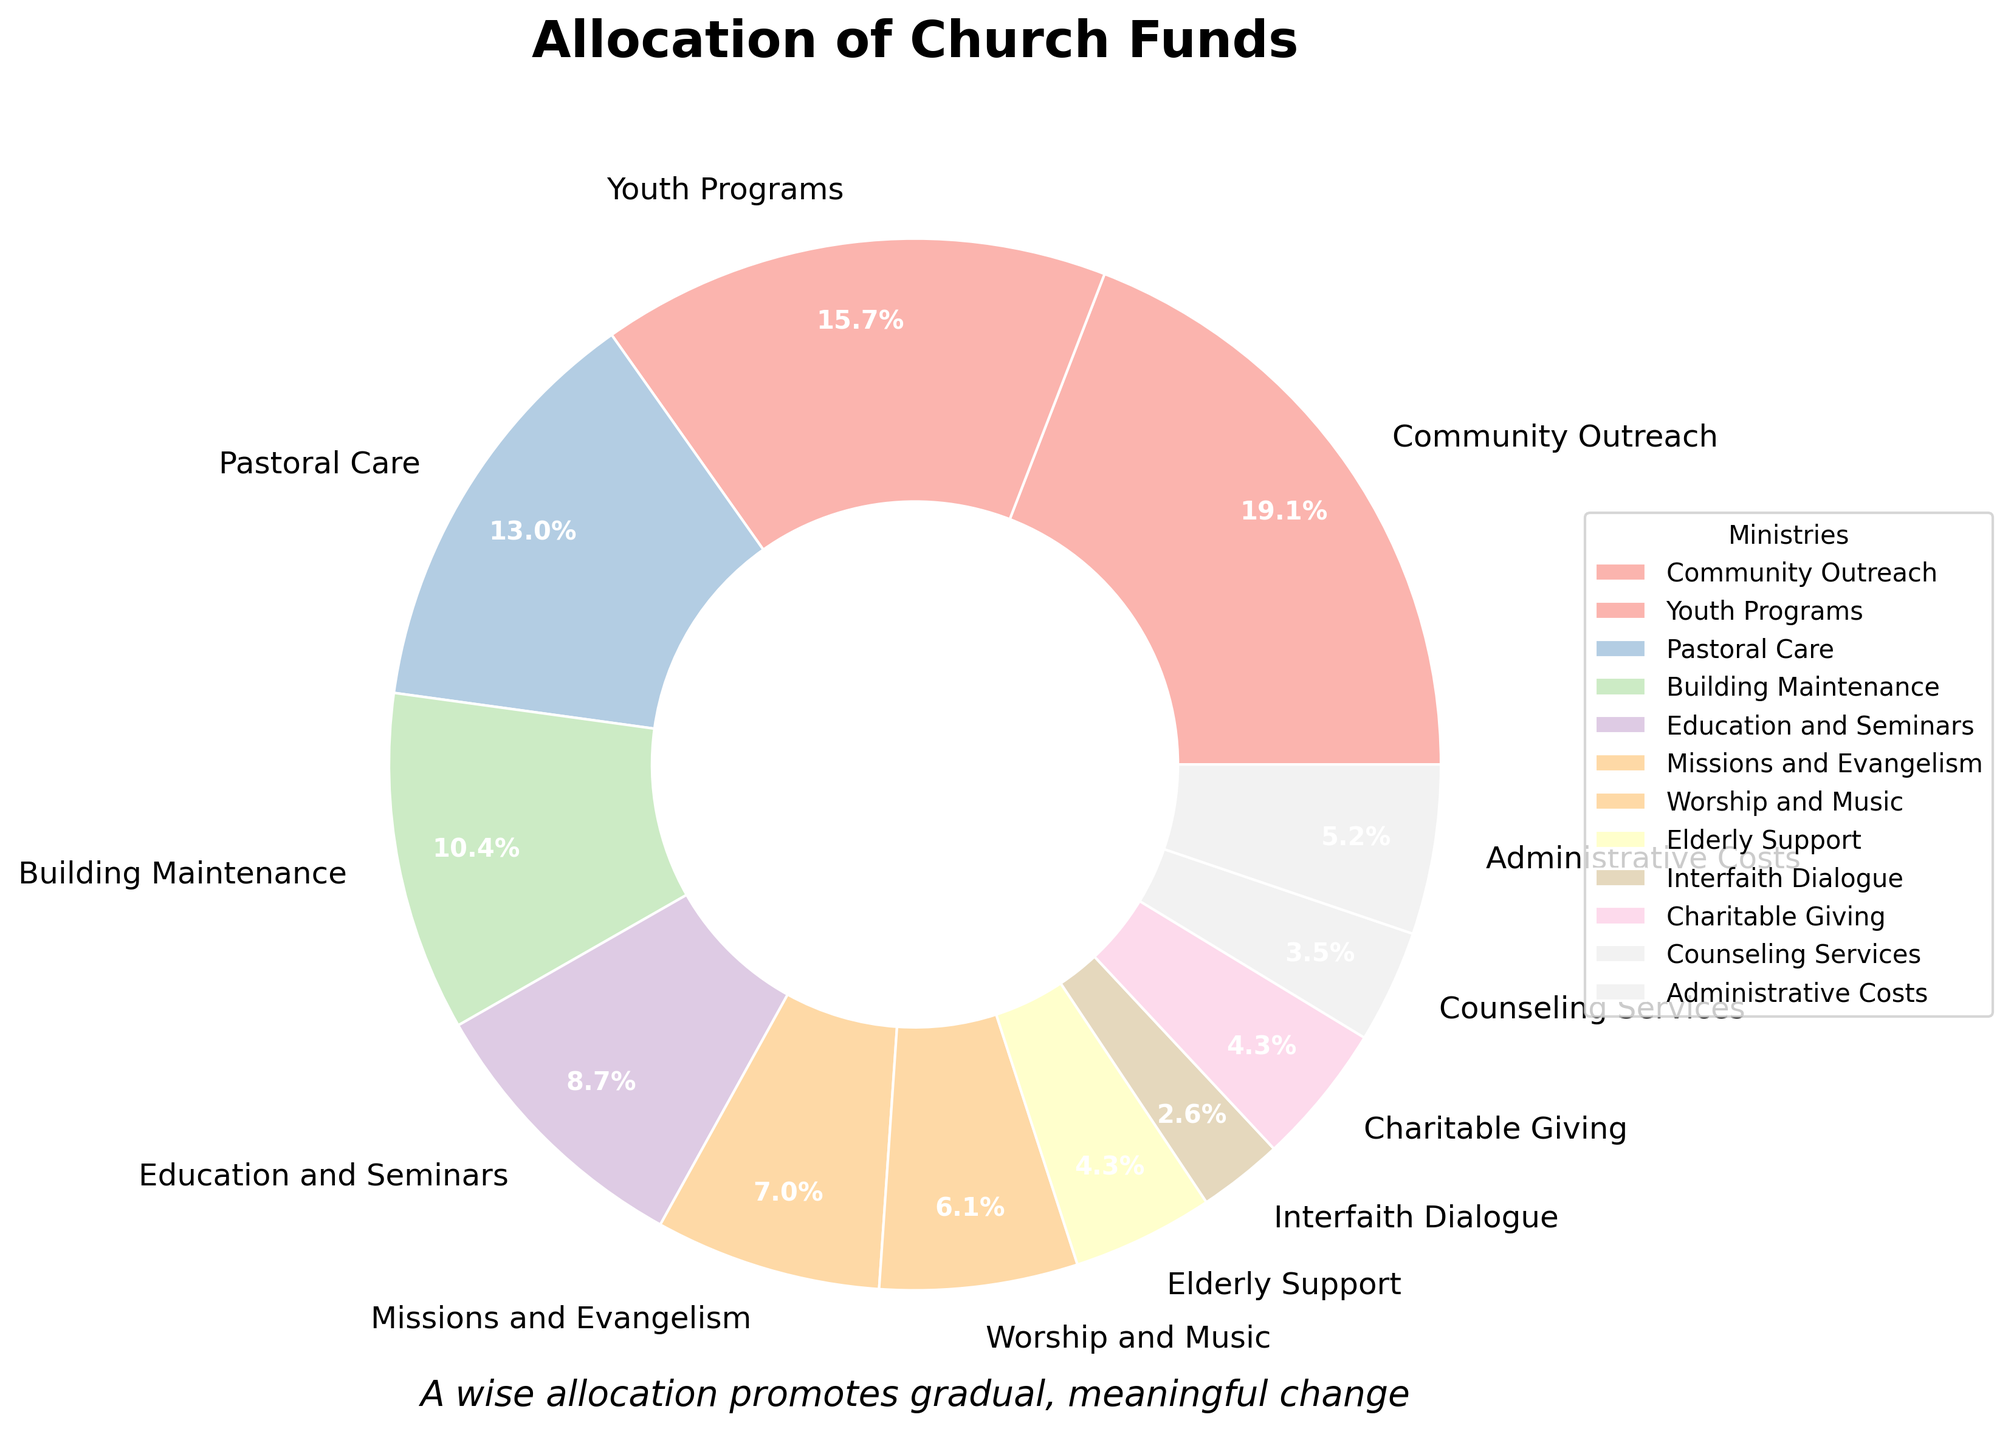What percentage of the funds is allocated to Youth Programs and Pastoral Care combined? To determine this, add the percentages of Youth Programs (18%) and Pastoral Care (15%). So, 18 + 15 = 33%.
Answer: 33% Which ministry receives the highest allocation of funds and what is the percentage? Looking at the pie chart, Community Outreach has the largest slice, corresponding to 22%.
Answer: Community Outreach, 22% How much more funding is given to Building Maintenance compared to Interfaith Dialogue? Compare the percentages for Building Maintenance (12%) and Interfaith Dialogue (3%). Subtract the smaller percentage from the larger one: 12 - 3 = 9%.
Answer: 9% Which two ministries have nearly equal allocations and what are their percentages? From the chart, Charitable Giving and Elderly Support each receive close to 5% allocation.
Answer: Charitable Giving and Elderly Support, 5% What is the combined percentage for Education and Seminars, Missions and Evangelism, and Worship and Music? Add the percentages of Education and Seminars (10%), Missions and Evangelism (8%), and Worship and Music (7%). So, 10 + 8 + 7 = 25%.
Answer: 25% Which ministry receives the smallest allocation of funds and what is the percentage? By observing the chart, Interfaith Dialogue has the smallest slice, corresponding to 3%.
Answer: Interfaith Dialogue, 3% Determine the ratio of allocation between Community Outreach and Counseling Services. The percentages are 22% for Community Outreach and 4% for Counseling Services. The ratio is 22:4. Simplify this to 11:2.
Answer: 11:2 How much more funding percentage-wise is allocated to Administrative Costs than to Counseling Services? Administrative Costs receive 6%, and Counseling Services receive 4%. Subtract the smaller percentage from the larger one: 6 - 4 = 2%.
Answer: 2% Combine the allocations of all programs other than the Community Outreach, what is the result percentage? Subtract Community Outreach's percentage from 100% to get the sum of others: 100 - 22 = 78%.
Answer: 78% 